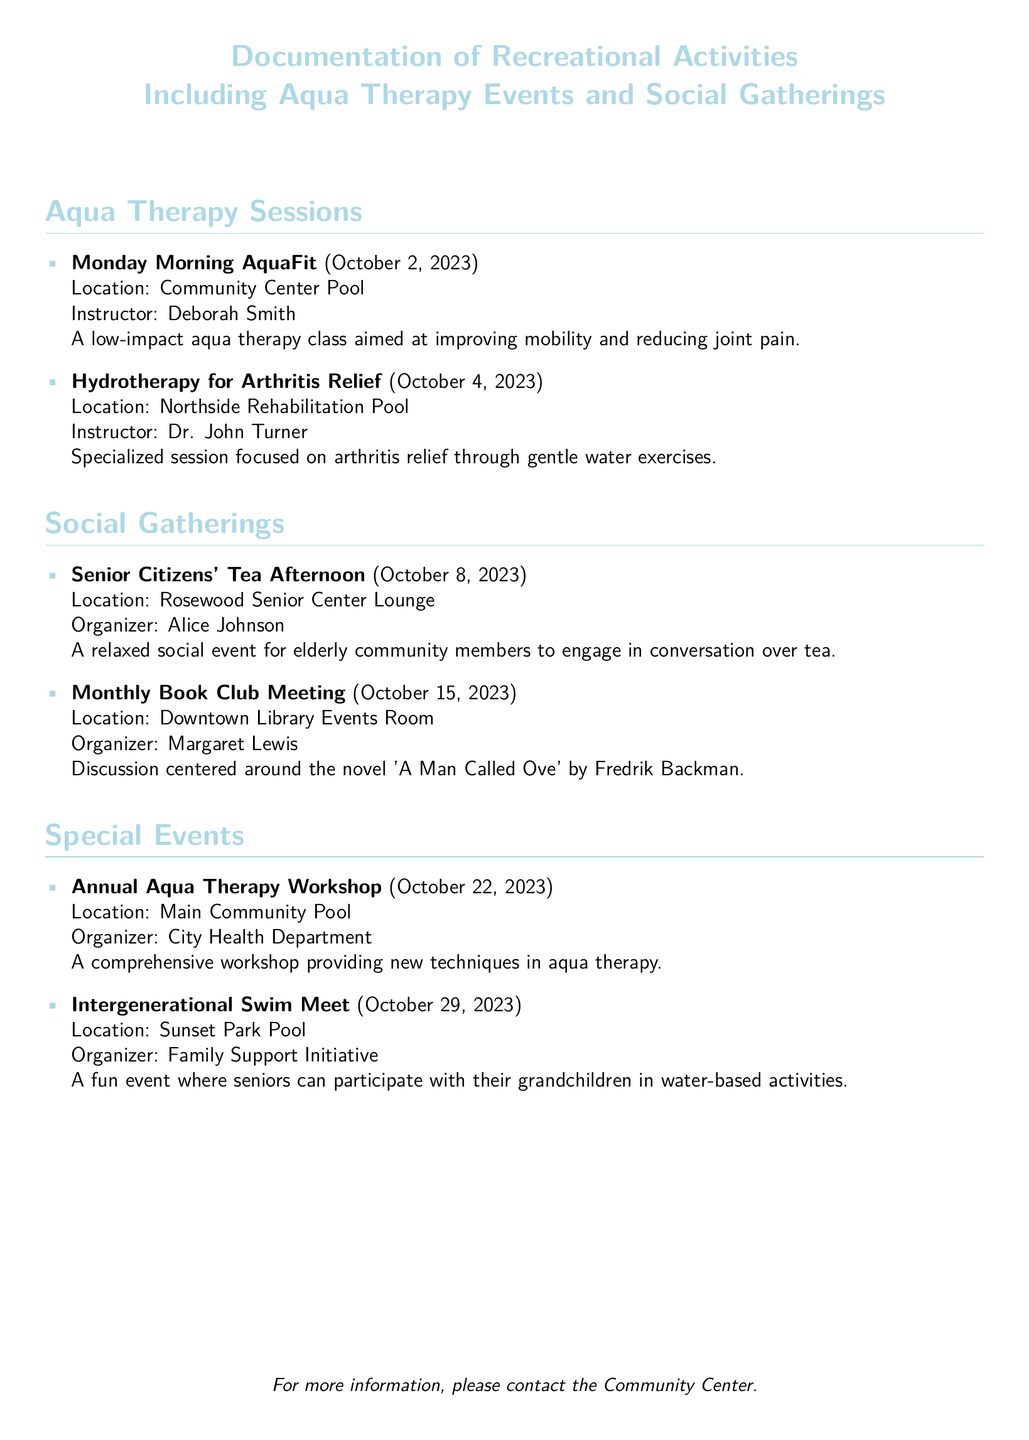What is the location of the Monday Morning AquaFit session? The location is specified in the document as the Community Center Pool for the Monday Morning AquaFit session.
Answer: Community Center Pool Who is the instructor for Hydrotherapy for Arthritis Relief? The document lists Dr. John Turner as the instructor for the Hydrotherapy for Arthritis Relief session.
Answer: Dr. John Turner When is the Senior Citizens' Tea Afternoon? The date of the Senior Citizens' Tea Afternoon is mentioned in the document as October 8, 2023.
Answer: October 8, 2023 What is the title of the book discussed at the Monthly Book Club Meeting? The document indicates the book being discussed is 'A Man Called Ove' by Fredrik Backman during the Monthly Book Club Meeting.
Answer: 'A Man Called Ove' How many aqua therapy sessions are listed in the document? The document includes two types of aqua therapy sessions, specifically Monday Morning AquaFit and Hydrotherapy for Arthritis Relief.
Answer: Two What type of event is the Annual Aqua Therapy Workshop? The document classifies the Annual Aqua Therapy Workshop as a comprehensive workshop focusing on new techniques in aqua therapy.
Answer: Workshop What is the purpose of the Intergenerational Swim Meet? The document states that the purpose of the Intergenerational Swim Meet is to allow seniors to participate in water-based activities with their grandchildren.
Answer: Fun activities with grandchildren Who is the organizer of the Senior Citizens' Tea Afternoon? Alice Johnson is mentioned in the document as the organizer of the Senior Citizens' Tea Afternoon.
Answer: Alice Johnson 